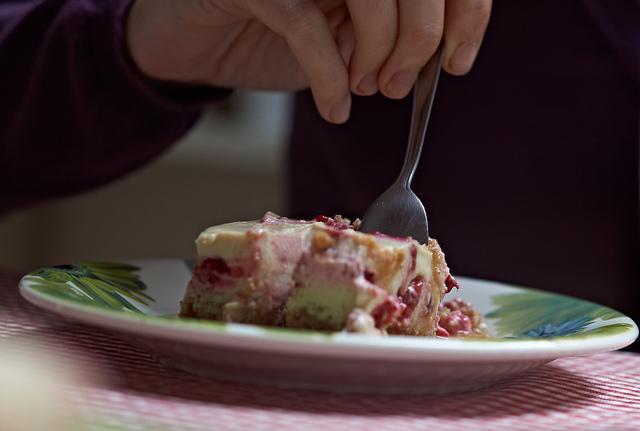How many bicycles are in the image?
Give a very brief answer. 0. 